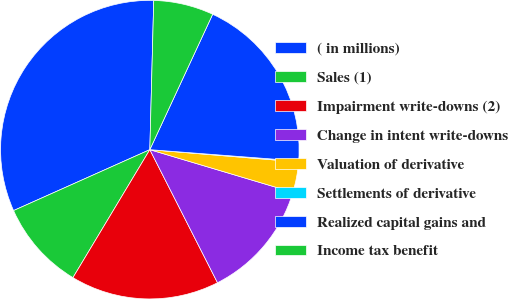Convert chart. <chart><loc_0><loc_0><loc_500><loc_500><pie_chart><fcel>( in millions)<fcel>Sales (1)<fcel>Impairment write-downs (2)<fcel>Change in intent write-downs<fcel>Valuation of derivative<fcel>Settlements of derivative<fcel>Realized capital gains and<fcel>Income tax benefit<nl><fcel>32.11%<fcel>9.7%<fcel>16.1%<fcel>12.9%<fcel>3.3%<fcel>0.1%<fcel>19.3%<fcel>6.5%<nl></chart> 